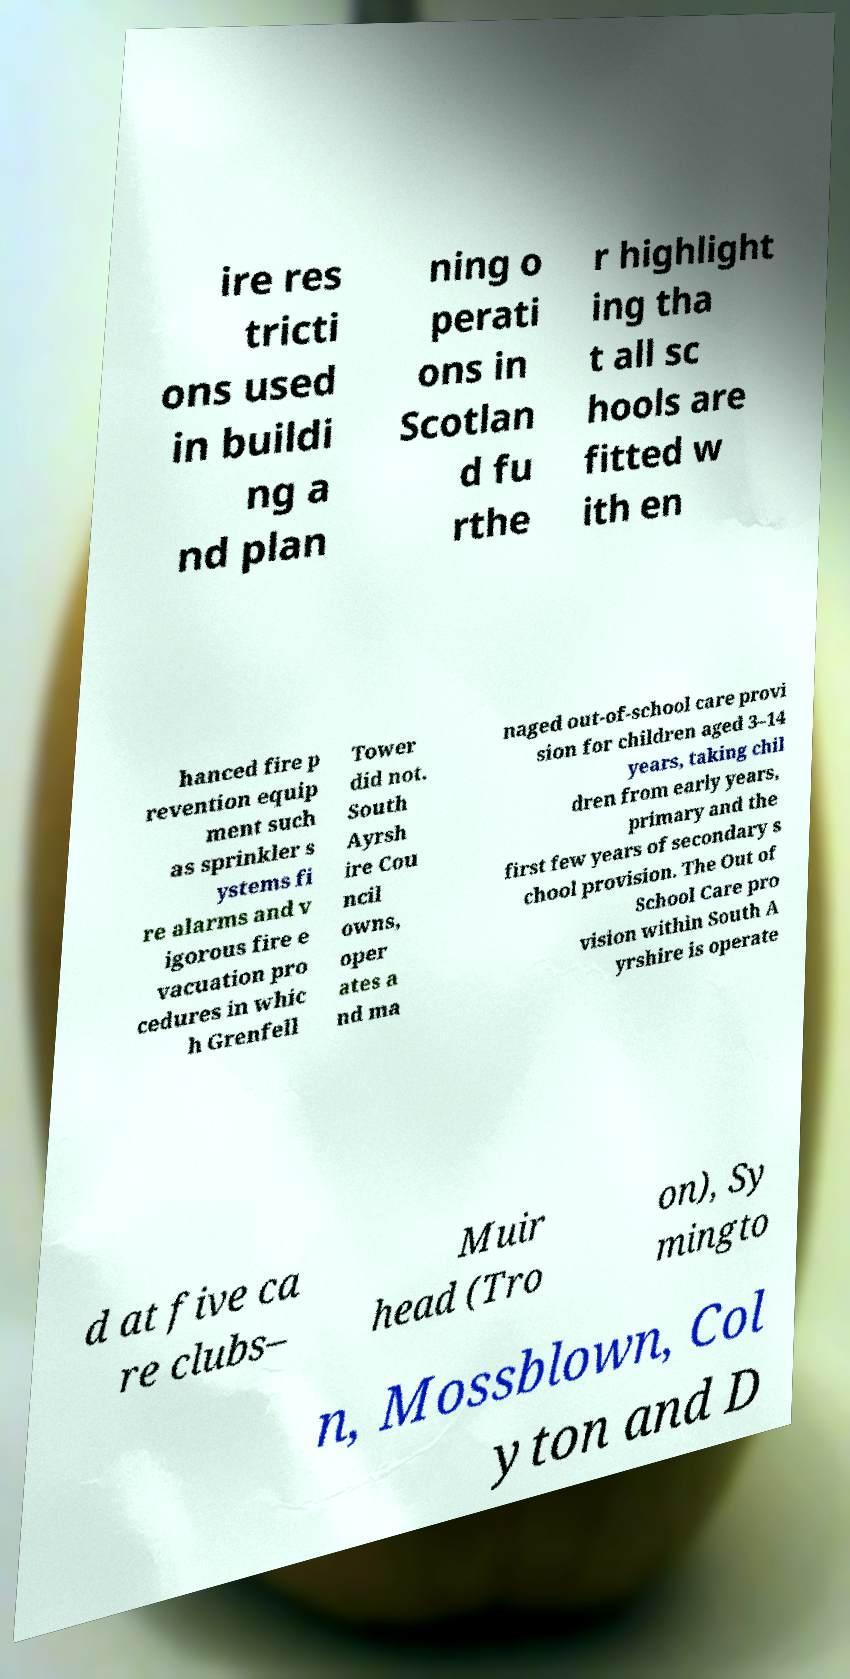For documentation purposes, I need the text within this image transcribed. Could you provide that? ire res tricti ons used in buildi ng a nd plan ning o perati ons in Scotlan d fu rthe r highlight ing tha t all sc hools are fitted w ith en hanced fire p revention equip ment such as sprinkler s ystems fi re alarms and v igorous fire e vacuation pro cedures in whic h Grenfell Tower did not. South Ayrsh ire Cou ncil owns, oper ates a nd ma naged out-of-school care provi sion for children aged 3–14 years, taking chil dren from early years, primary and the first few years of secondary s chool provision. The Out of School Care pro vision within South A yrshire is operate d at five ca re clubs– Muir head (Tro on), Sy mingto n, Mossblown, Col yton and D 